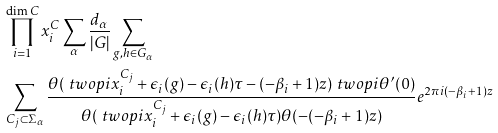Convert formula to latex. <formula><loc_0><loc_0><loc_500><loc_500>& \prod _ { i = 1 } ^ { \dim C } x ^ { C } _ { i } \sum _ { \alpha } \frac { d _ { \alpha } } { | G | } \sum _ { g , h \in G _ { \alpha } } \\ & \sum _ { C _ { j } \subset \Sigma _ { \alpha } } \frac { \theta ( \ t w o p i { x ^ { C _ { j } } _ { i } } + \epsilon _ { i } ( g ) - \epsilon _ { i } ( h ) \tau - ( - \beta _ { i } + 1 ) z ) \ t w o p i { \theta ^ { \prime } ( 0 ) } } { \theta ( \ t w o p i { x ^ { C _ { j } } _ { i } } + \epsilon _ { i } ( g ) - \epsilon _ { i } ( h ) \tau ) \theta ( - ( - \beta _ { i } + 1 ) z ) } e ^ { 2 \pi i ( - \beta _ { i } + 1 ) z }</formula> 